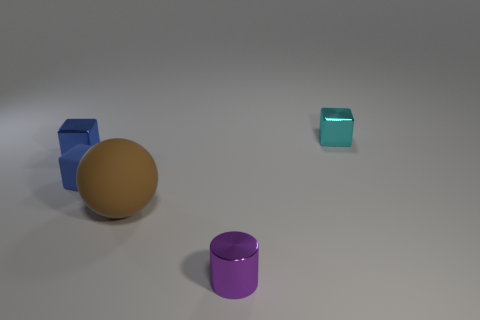Subtract all small blue blocks. How many blocks are left? 1 Add 4 large blue cylinders. How many objects exist? 9 Subtract 1 cylinders. How many cylinders are left? 0 Subtract all cyan blocks. How many blocks are left? 2 Subtract all blocks. How many objects are left? 2 Subtract all cyan spheres. How many gray cubes are left? 0 Add 4 purple cylinders. How many purple cylinders exist? 5 Subtract 0 green cylinders. How many objects are left? 5 Subtract all green cubes. Subtract all brown cylinders. How many cubes are left? 3 Subtract all big things. Subtract all blue matte blocks. How many objects are left? 3 